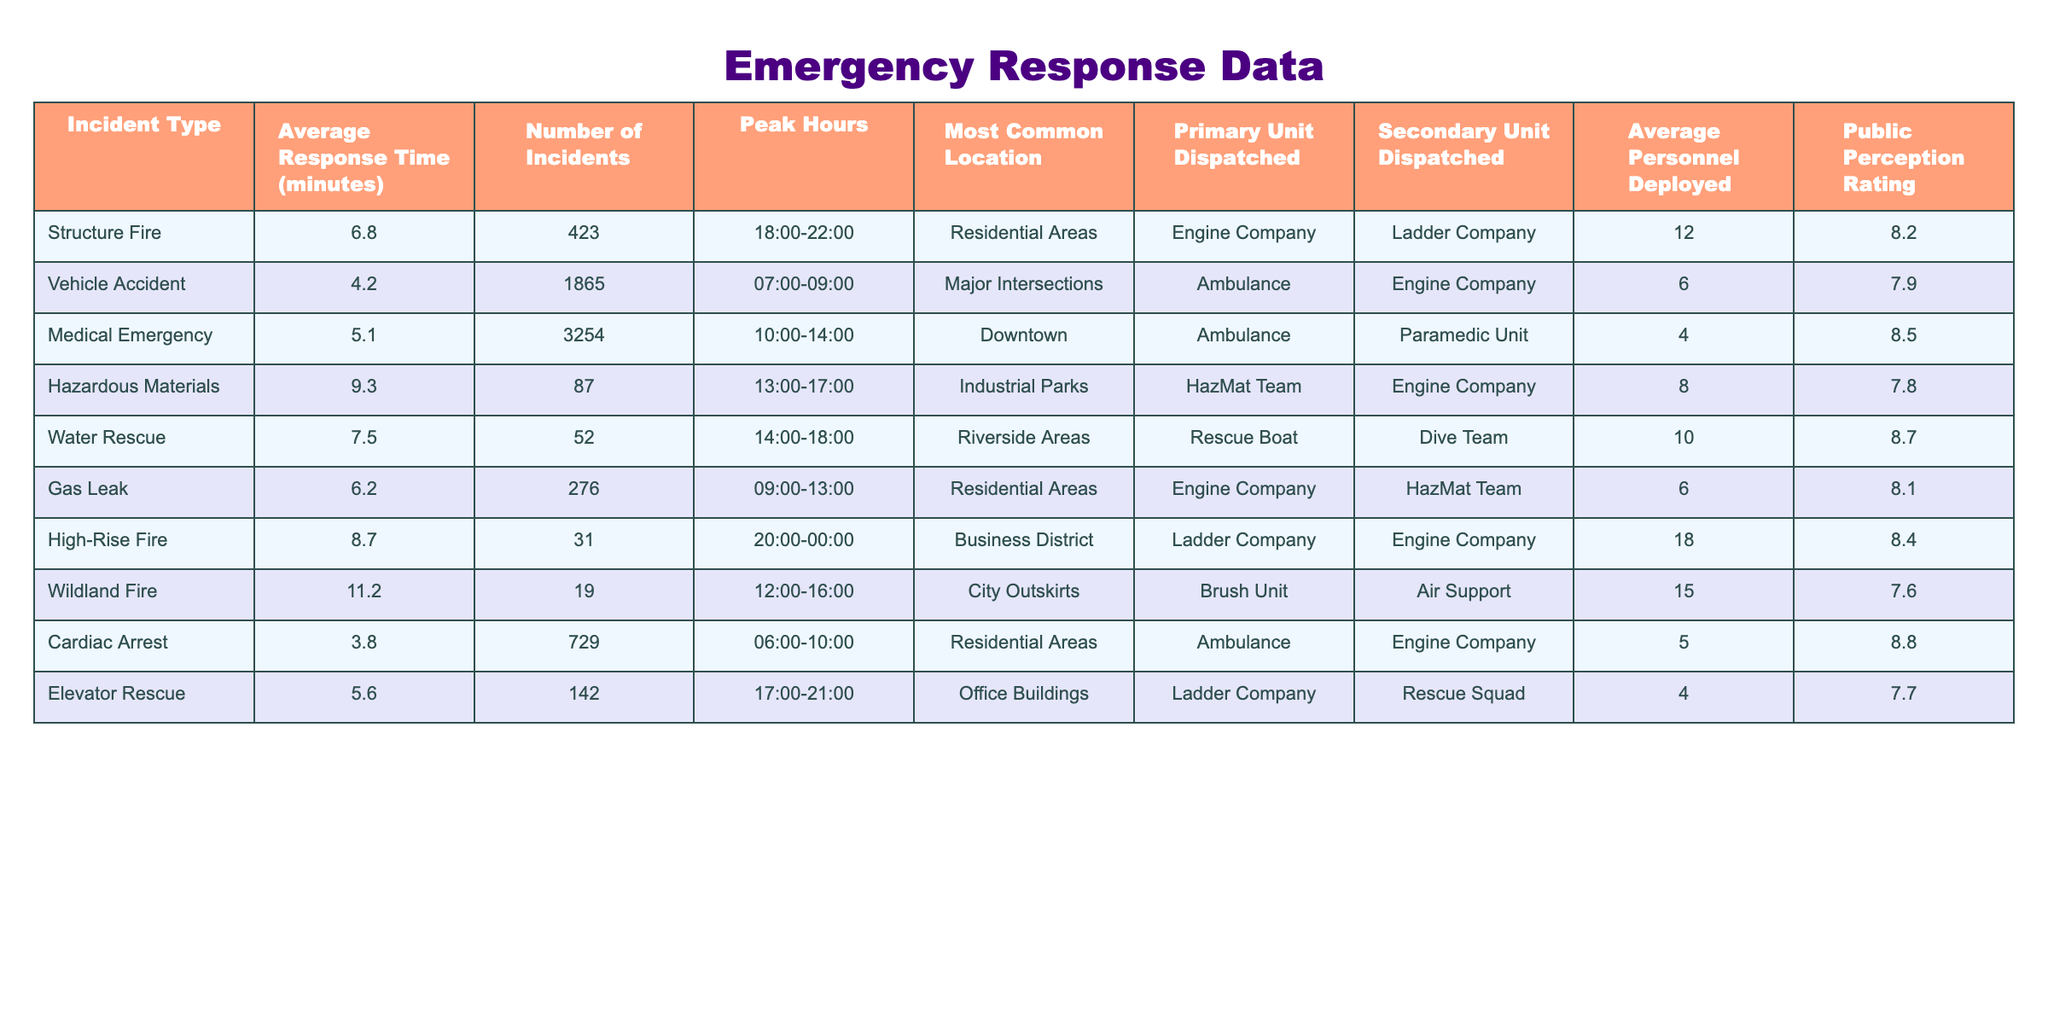What is the average response time for a vehicle accident? Referring to the table, the average response time for a vehicle accident is listed under the column "Average Response Time (minutes)" corresponding to "Vehicle Accident." The value is 4.2 minutes.
Answer: 4.2 minutes Which incident type has the highest public perception rating? By examining the "Public Perception Rating" column, the highest rating is 8.8, which corresponds to "Cardiac Arrest."
Answer: Cardiac Arrest How many incidents were reported for high-rise fires? The "Number of Incidents" column indicates that there were 31 incidents reported for high-rise fires.
Answer: 31 What is the difference in average response time between medical emergencies and hazardous materials incidents? The average response time for medical emergencies is 5.1 minutes, while for hazardous materials, it is 9.3 minutes. The difference is 9.3 - 5.1 = 4.2 minutes.
Answer: 4.2 minutes True or False: More structure fires occurred than water rescues. Checking the "Number of Incidents" column, structure fires had 423 incidents, whereas water rescues had only 52 incidents. Thus, it's true that more structure fires occurred than water rescues.
Answer: True What is the average personnel deployed for gas leak incidents? The value in the "Average Personnel Deployed" column for gas leak incidents is 6, which indicates the average number of personnel dispatched for this incident type.
Answer: 6 If we combine the number of incidents for vehicle accidents and medical emergencies, what is the total? Vehicle accidents account for 1865 incidents, and medical emergencies have 3254 incidents. Adding these together yields 1865 + 3254 = 5119 incidents.
Answer: 5119 Which incident type occurs most frequently in residential areas? From the table, vehicle accidents, gas leaks, and cardiac arrests all occur in residential areas. However, vehicle accidents have the highest number of incidents at 1865. Therefore, vehicle accidents occur most frequently in residential areas.
Answer: Vehicle Accident What is the total public perception rating of all incident types? Summing the public perception ratings for all incident types: 8.2 + 7.9 + 8.5 + 7.8 + 8.7 + 8.1 + 8.4 + 7.6 + 8.8 + 7.7 = 78.7.
Answer: 78.7 How many types of incidents are reported for peak hours between 14:00 and 18:00? The data shows that only "Water Rescue" and "Medical Emergency" fall within peak hours of that timeframe. Thus, there are 2 incident types during those hours.
Answer: 2 